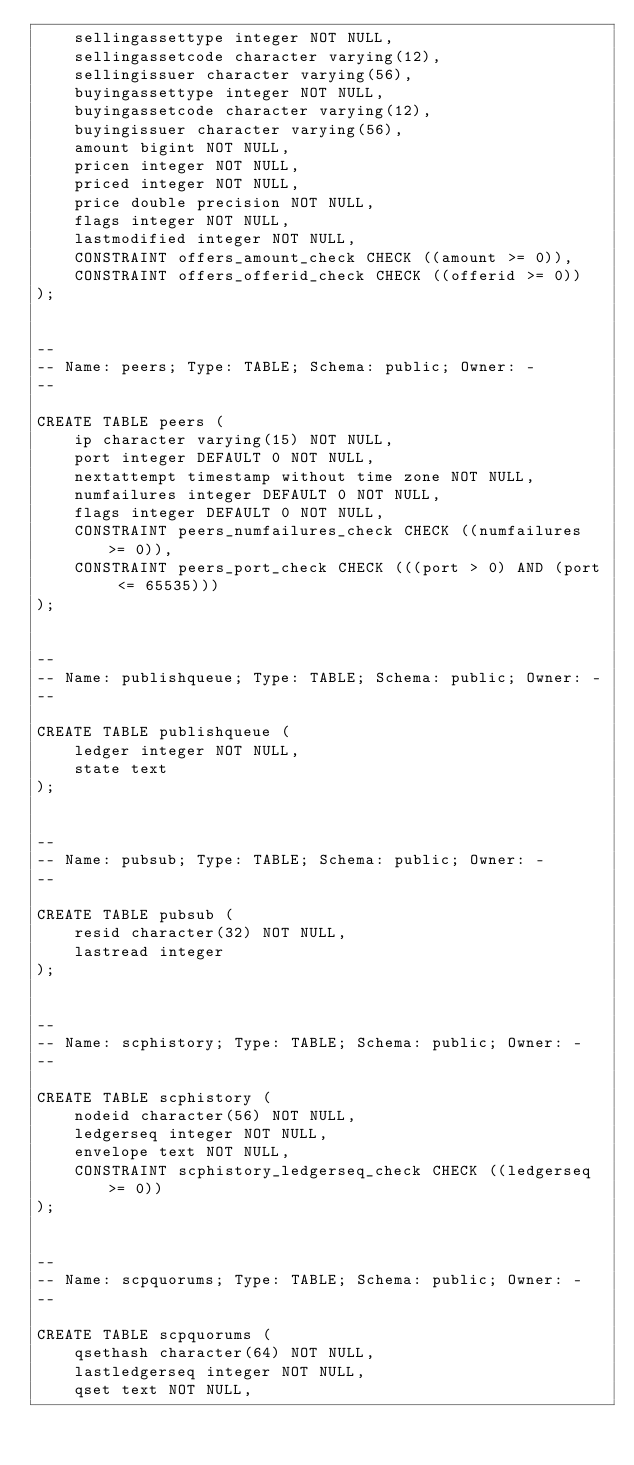Convert code to text. <code><loc_0><loc_0><loc_500><loc_500><_SQL_>    sellingassettype integer NOT NULL,
    sellingassetcode character varying(12),
    sellingissuer character varying(56),
    buyingassettype integer NOT NULL,
    buyingassetcode character varying(12),
    buyingissuer character varying(56),
    amount bigint NOT NULL,
    pricen integer NOT NULL,
    priced integer NOT NULL,
    price double precision NOT NULL,
    flags integer NOT NULL,
    lastmodified integer NOT NULL,
    CONSTRAINT offers_amount_check CHECK ((amount >= 0)),
    CONSTRAINT offers_offerid_check CHECK ((offerid >= 0))
);


--
-- Name: peers; Type: TABLE; Schema: public; Owner: -
--

CREATE TABLE peers (
    ip character varying(15) NOT NULL,
    port integer DEFAULT 0 NOT NULL,
    nextattempt timestamp without time zone NOT NULL,
    numfailures integer DEFAULT 0 NOT NULL,
    flags integer DEFAULT 0 NOT NULL,
    CONSTRAINT peers_numfailures_check CHECK ((numfailures >= 0)),
    CONSTRAINT peers_port_check CHECK (((port > 0) AND (port <= 65535)))
);


--
-- Name: publishqueue; Type: TABLE; Schema: public; Owner: -
--

CREATE TABLE publishqueue (
    ledger integer NOT NULL,
    state text
);


--
-- Name: pubsub; Type: TABLE; Schema: public; Owner: -
--

CREATE TABLE pubsub (
    resid character(32) NOT NULL,
    lastread integer
);


--
-- Name: scphistory; Type: TABLE; Schema: public; Owner: -
--

CREATE TABLE scphistory (
    nodeid character(56) NOT NULL,
    ledgerseq integer NOT NULL,
    envelope text NOT NULL,
    CONSTRAINT scphistory_ledgerseq_check CHECK ((ledgerseq >= 0))
);


--
-- Name: scpquorums; Type: TABLE; Schema: public; Owner: -
--

CREATE TABLE scpquorums (
    qsethash character(64) NOT NULL,
    lastledgerseq integer NOT NULL,
    qset text NOT NULL,</code> 